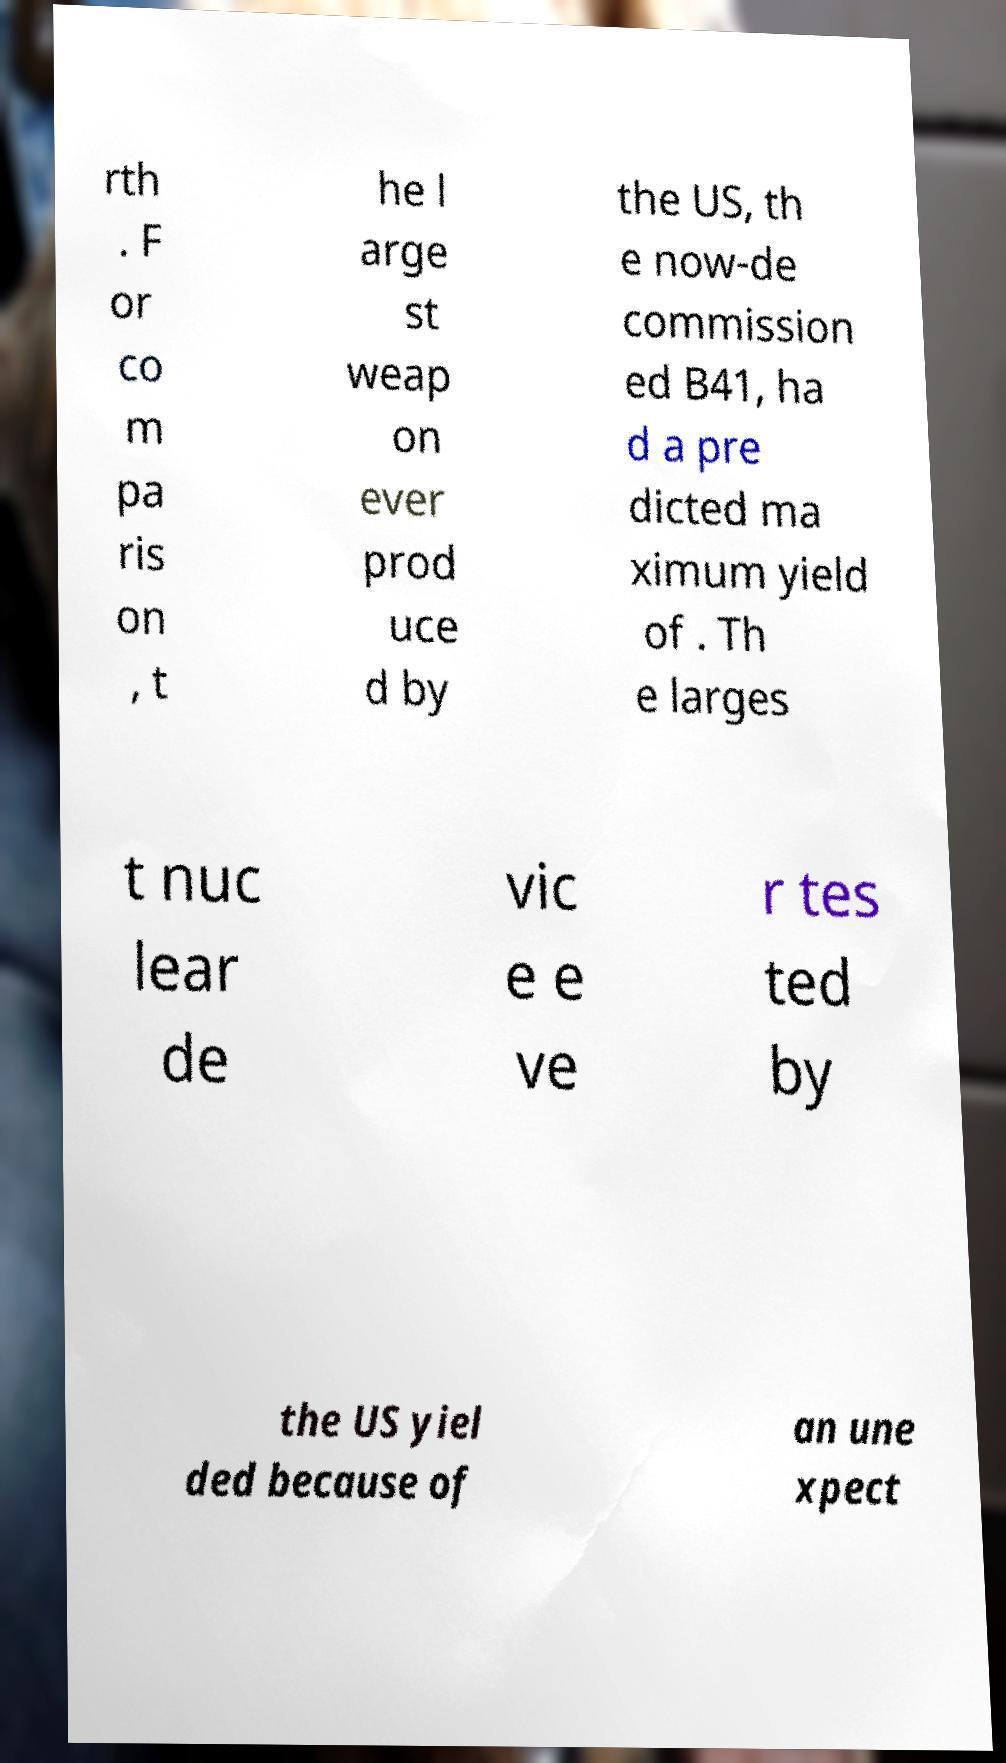There's text embedded in this image that I need extracted. Can you transcribe it verbatim? rth . F or co m pa ris on , t he l arge st weap on ever prod uce d by the US, th e now-de commission ed B41, ha d a pre dicted ma ximum yield of . Th e larges t nuc lear de vic e e ve r tes ted by the US yiel ded because of an une xpect 